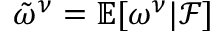<formula> <loc_0><loc_0><loc_500><loc_500>\tilde { \omega } ^ { \nu } = \mathbb { E } [ \omega ^ { \nu } | \mathcal { F } ]</formula> 